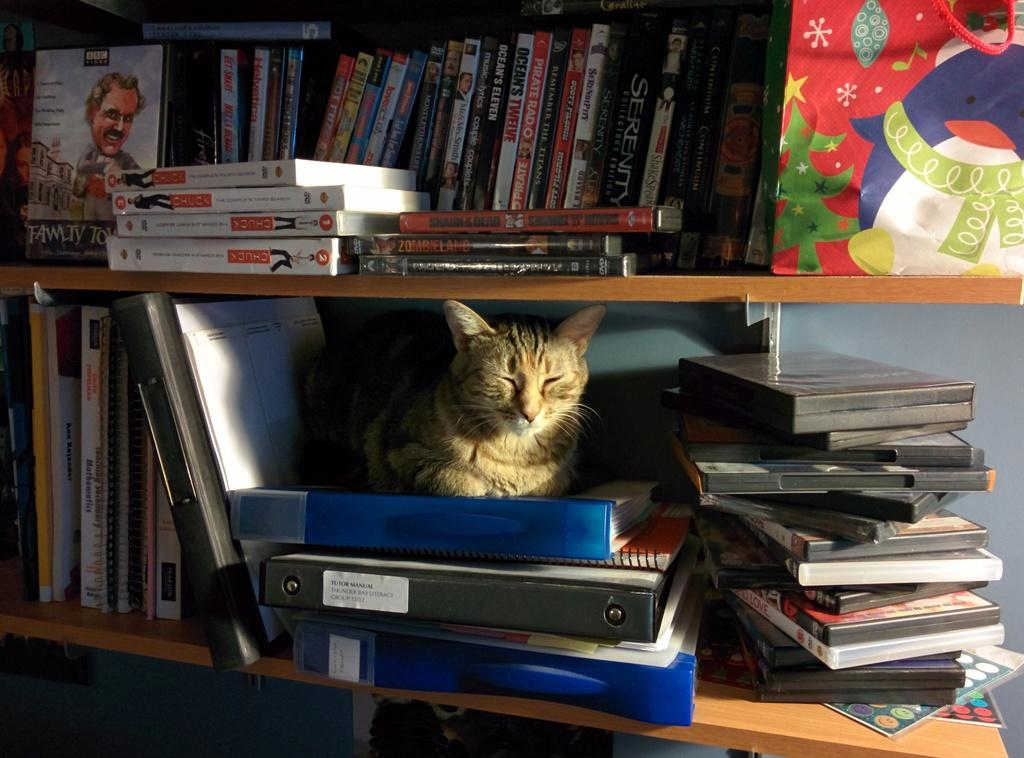What type of animal is present in the image? There is a cat in the image. What is the cat doing in the image? The cat is sleeping. Where is the cat located in the image? The cat is on the flies. What can be seen on the shelf in the image? There are compact discs arranged on a shelf in the image. What type of oatmeal is the cat eating in the image? There is no oatmeal present in the image; the cat is sleeping on the flies. 